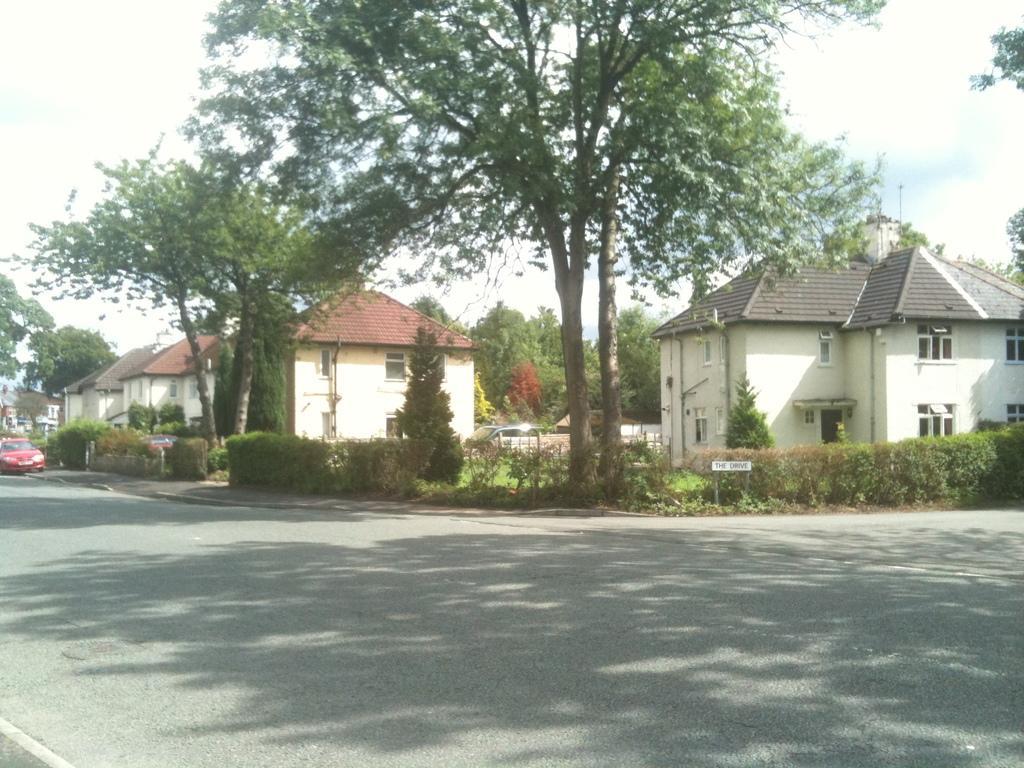Can you describe this image briefly? At the bottom of the image we can see road. In the center of the image we can see trees. On the right and left side of the image we can see houses and trees. In the background we can see trees, sky and clouds. 